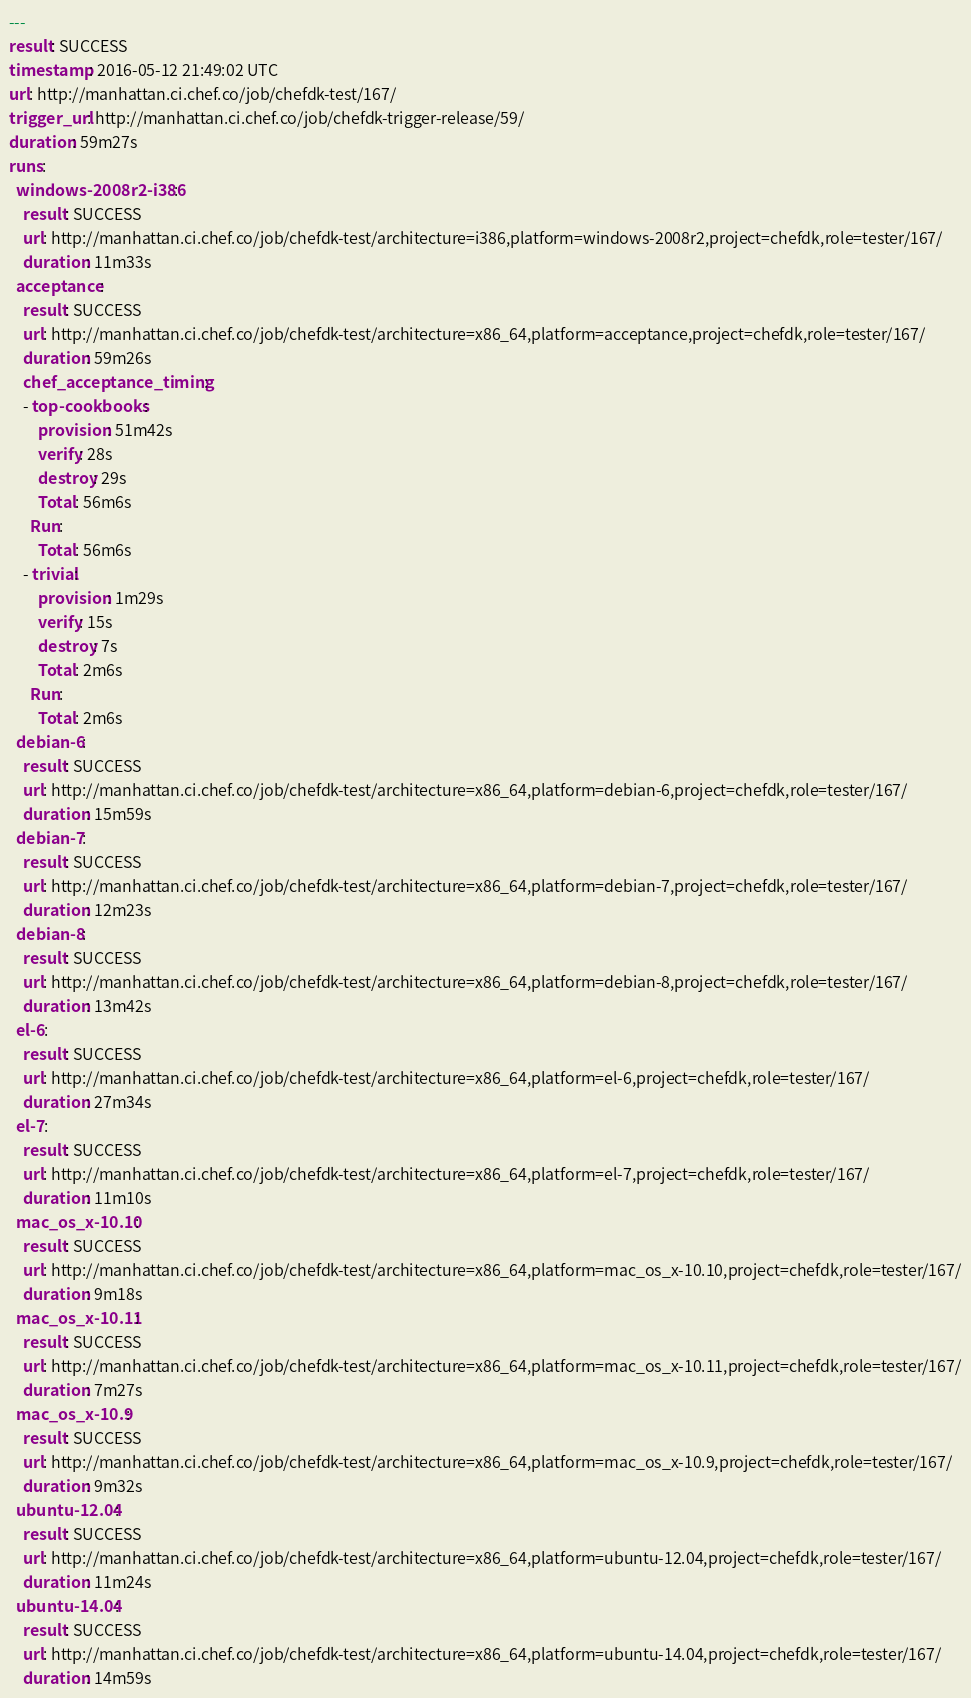Convert code to text. <code><loc_0><loc_0><loc_500><loc_500><_YAML_>---
result: SUCCESS
timestamp: 2016-05-12 21:49:02 UTC
url: http://manhattan.ci.chef.co/job/chefdk-test/167/
trigger_url: http://manhattan.ci.chef.co/job/chefdk-trigger-release/59/
duration: 59m27s
runs:
  windows-2008r2-i386:
    result: SUCCESS
    url: http://manhattan.ci.chef.co/job/chefdk-test/architecture=i386,platform=windows-2008r2,project=chefdk,role=tester/167/
    duration: 11m33s
  acceptance:
    result: SUCCESS
    url: http://manhattan.ci.chef.co/job/chefdk-test/architecture=x86_64,platform=acceptance,project=chefdk,role=tester/167/
    duration: 59m26s
    chef_acceptance_timing:
    - top-cookbooks:
        provision: 51m42s
        verify: 28s
        destroy: 29s
        Total: 56m6s
      Run:
        Total: 56m6s
    - trivial:
        provision: 1m29s
        verify: 15s
        destroy: 7s
        Total: 2m6s
      Run:
        Total: 2m6s
  debian-6:
    result: SUCCESS
    url: http://manhattan.ci.chef.co/job/chefdk-test/architecture=x86_64,platform=debian-6,project=chefdk,role=tester/167/
    duration: 15m59s
  debian-7:
    result: SUCCESS
    url: http://manhattan.ci.chef.co/job/chefdk-test/architecture=x86_64,platform=debian-7,project=chefdk,role=tester/167/
    duration: 12m23s
  debian-8:
    result: SUCCESS
    url: http://manhattan.ci.chef.co/job/chefdk-test/architecture=x86_64,platform=debian-8,project=chefdk,role=tester/167/
    duration: 13m42s
  el-6:
    result: SUCCESS
    url: http://manhattan.ci.chef.co/job/chefdk-test/architecture=x86_64,platform=el-6,project=chefdk,role=tester/167/
    duration: 27m34s
  el-7:
    result: SUCCESS
    url: http://manhattan.ci.chef.co/job/chefdk-test/architecture=x86_64,platform=el-7,project=chefdk,role=tester/167/
    duration: 11m10s
  mac_os_x-10.10:
    result: SUCCESS
    url: http://manhattan.ci.chef.co/job/chefdk-test/architecture=x86_64,platform=mac_os_x-10.10,project=chefdk,role=tester/167/
    duration: 9m18s
  mac_os_x-10.11:
    result: SUCCESS
    url: http://manhattan.ci.chef.co/job/chefdk-test/architecture=x86_64,platform=mac_os_x-10.11,project=chefdk,role=tester/167/
    duration: 7m27s
  mac_os_x-10.9:
    result: SUCCESS
    url: http://manhattan.ci.chef.co/job/chefdk-test/architecture=x86_64,platform=mac_os_x-10.9,project=chefdk,role=tester/167/
    duration: 9m32s
  ubuntu-12.04:
    result: SUCCESS
    url: http://manhattan.ci.chef.co/job/chefdk-test/architecture=x86_64,platform=ubuntu-12.04,project=chefdk,role=tester/167/
    duration: 11m24s
  ubuntu-14.04:
    result: SUCCESS
    url: http://manhattan.ci.chef.co/job/chefdk-test/architecture=x86_64,platform=ubuntu-14.04,project=chefdk,role=tester/167/
    duration: 14m59s
</code> 